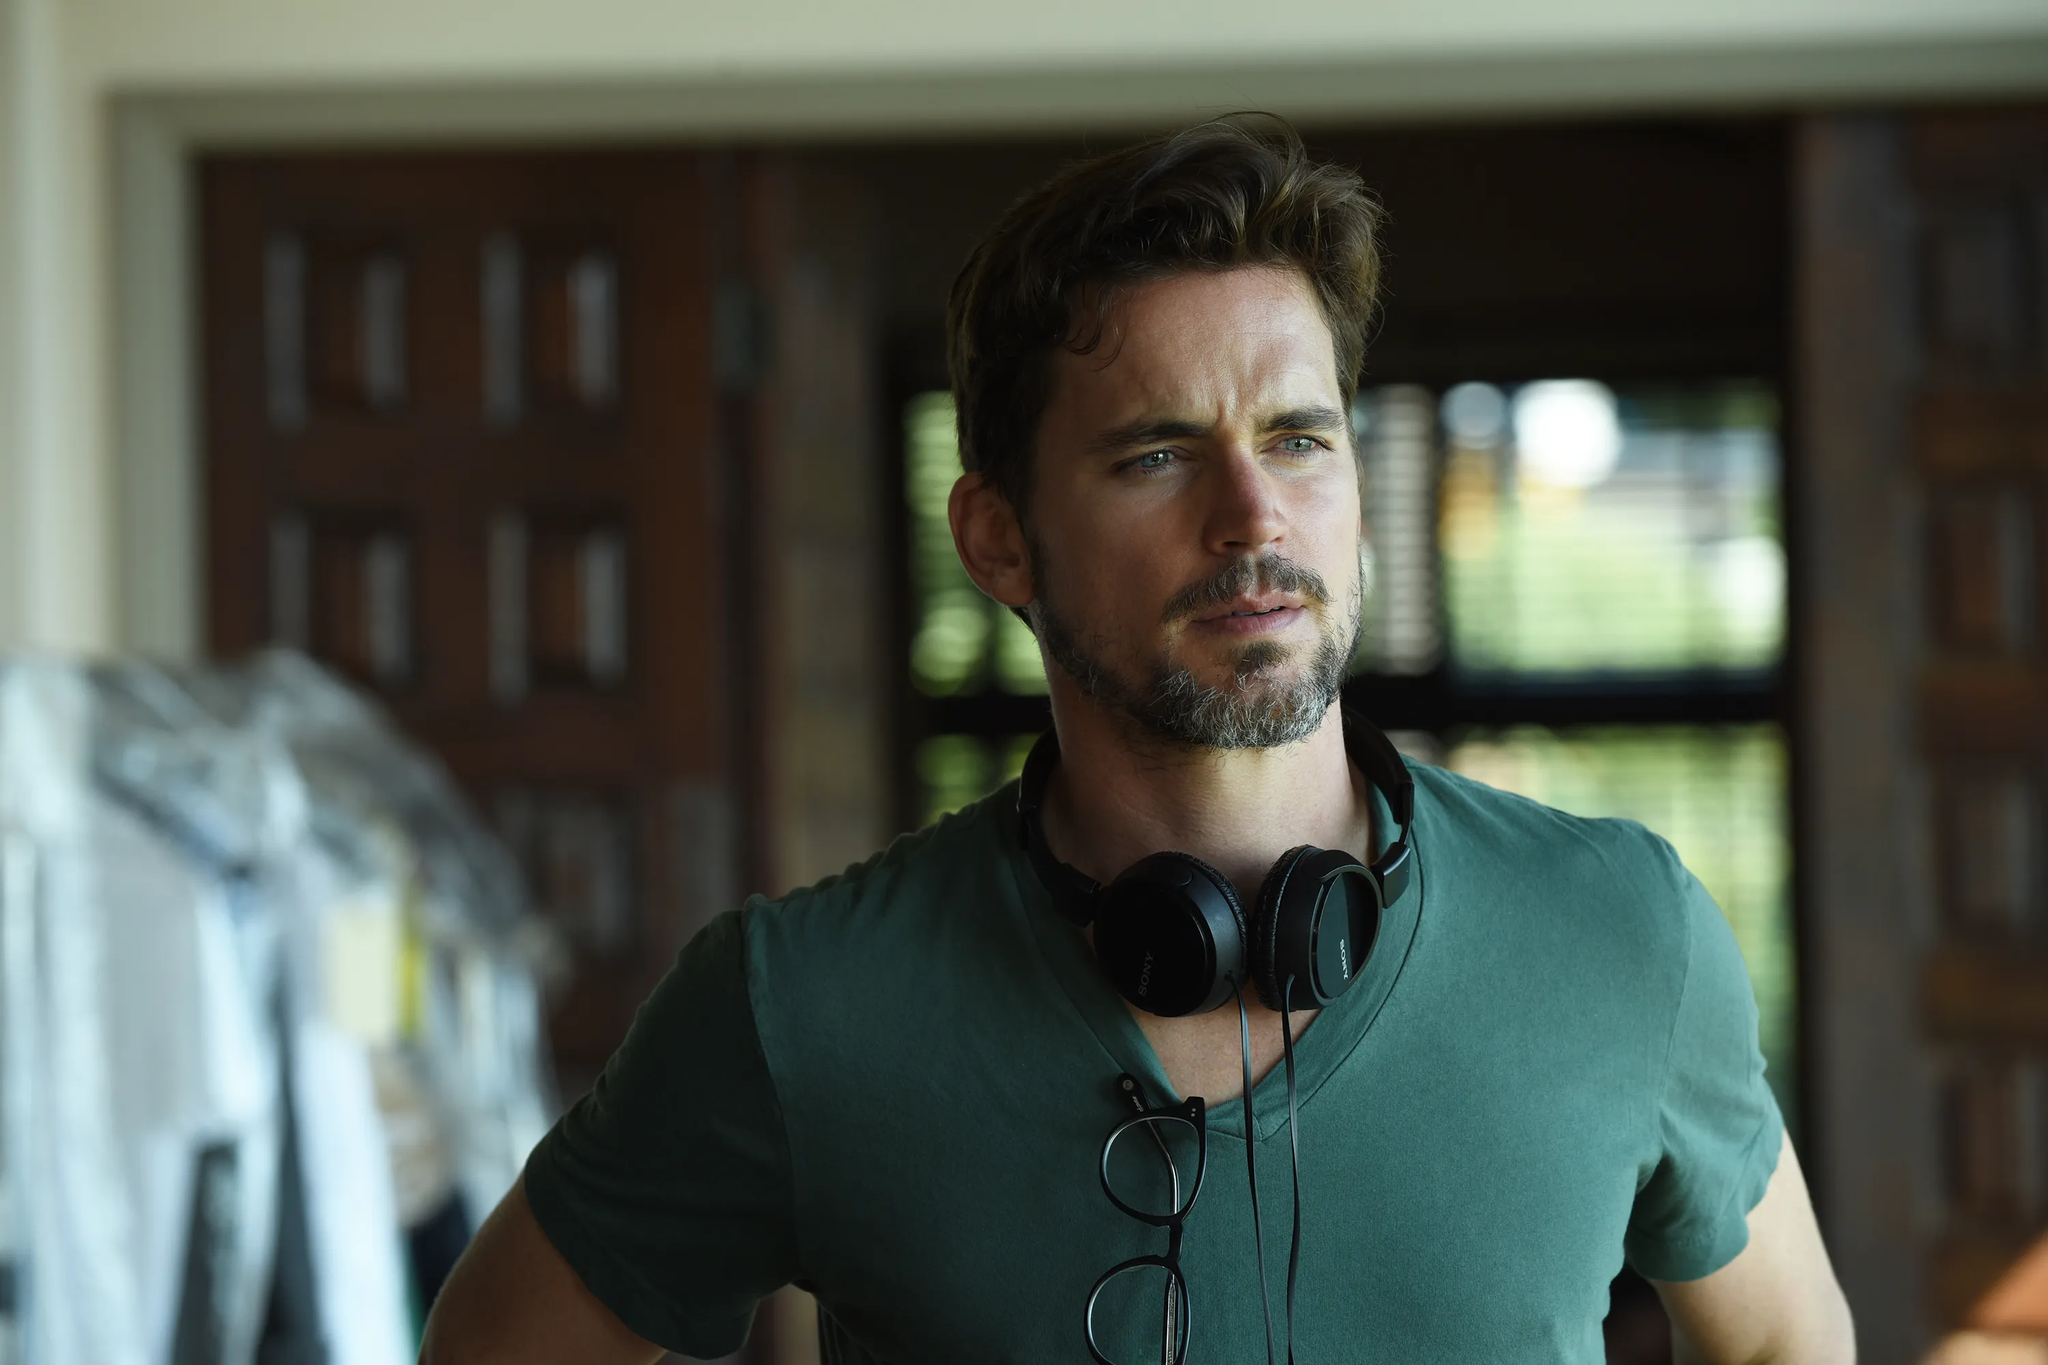If this were in a music video, what would be the theme? In a music video, this image could represent a theme of introspection and self-discovery. The man might be an artist reflecting on his journey or contemplating his future, with the rustic setting symbolizing a return to basics or roots. The headphones signify the importance of music in his life, possibly guiding him through this introspective phase. 